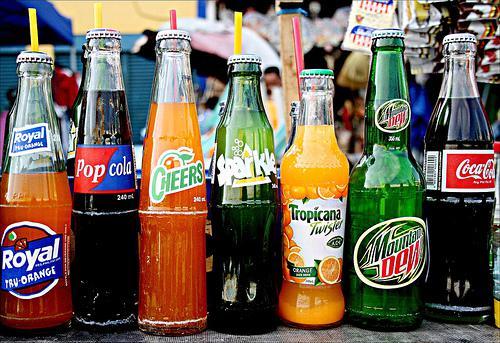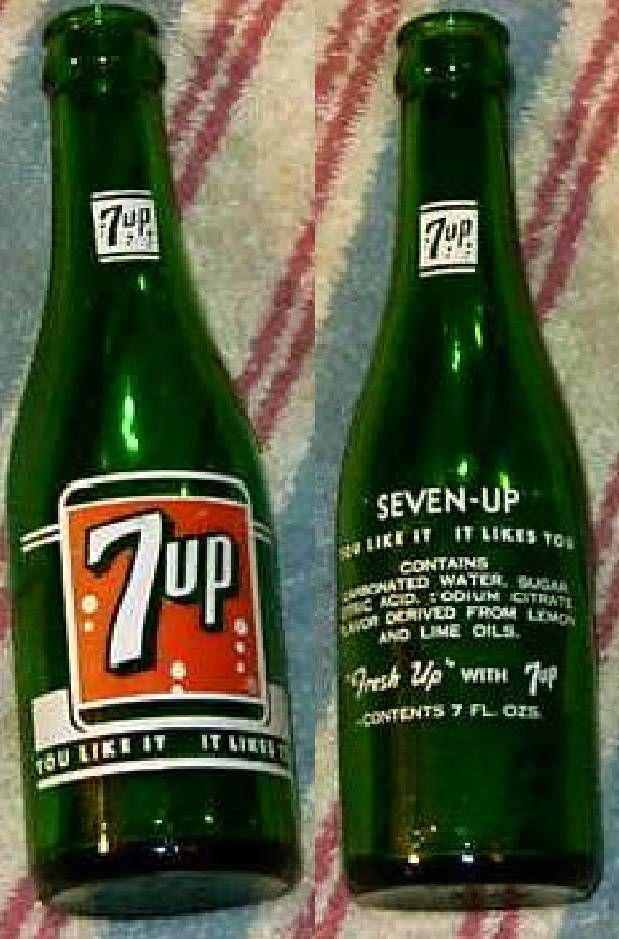The first image is the image on the left, the second image is the image on the right. Given the left and right images, does the statement "There are exactly seven bottles in total." hold true? Answer yes or no. No. The first image is the image on the left, the second image is the image on the right. For the images shown, is this caption "There are seven bottles in total." true? Answer yes or no. No. 